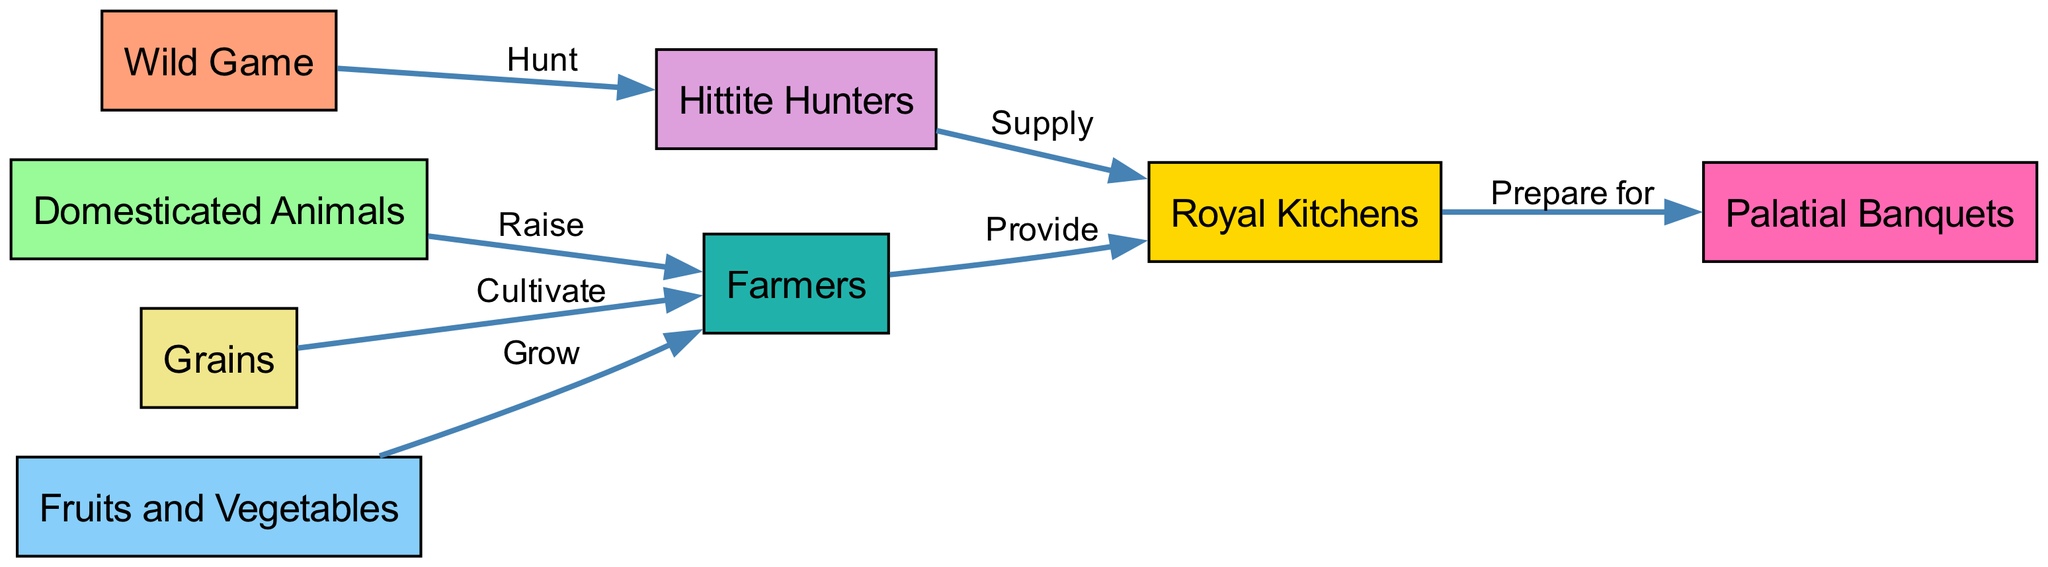What is the first node in the food chain? The first node is "Wild Game," which indicates the initial source of food deriving from hunting activities.
Answer: Wild Game How many nodes are in the diagram? By counting each node listed in the data, we find there are a total of 8 nodes representing different elements of the foodways.
Answer: 8 Which node is connected to the "Farmers" node? Two nodes connect to "Farmers"; they are "Domesticated Animals," which are raised by farmers, and "Grains," which farmers cultivate.
Answer: Domesticated Animals, Grains What is the label for the edge from "Hittite Hunters" to "Royal Kitchens"? The edge from "Hittite Hunters" to "Royal Kitchens" is labeled "Supply," indicating the action of delivering food from hunters to the kitchens.
Answer: Supply Which node provides food for the "Palatial Banquets"? The "Royal Kitchens" node is responsible for preparing food, which provides the meals for "Palatial Banquets," showcasing the transition from the kitchen to dining.
Answer: Royal Kitchens How many edges indicate a relationship between "Farmers" and "Royal Kitchens"? There are two edges connecting "Farmers" to "Royal Kitchens": one from the "Farmers" node indicating "Provide" and another from the "Hittite Hunters" indicating "Supply."
Answer: 2 What is the role of "Hittite Hunters" in relation to the food chain? "Hittite Hunters" supply food to the royal kitchens by hunting wild game, establishing their role as primary suppliers in the food chain.
Answer: Supply How do "Grains" reach the "Royal Kitchens"? "Grains" are cultivated by "Farmers," who then provide them to "Royal Kitchens," showcasing the process of food preparation from agriculture to the kitchen.
Answer: Provide 